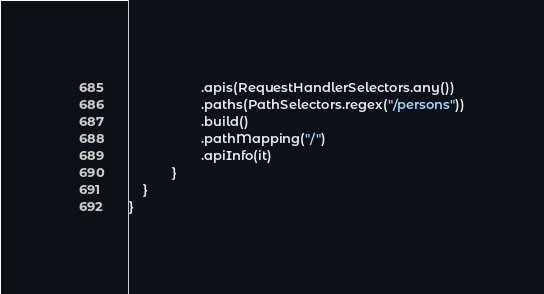<code> <loc_0><loc_0><loc_500><loc_500><_Kotlin_>                    .apis(RequestHandlerSelectors.any())
                    .paths(PathSelectors.regex("/persons"))
                    .build()
                    .pathMapping("/")
                    .apiInfo(it)
            }
    }
}</code> 